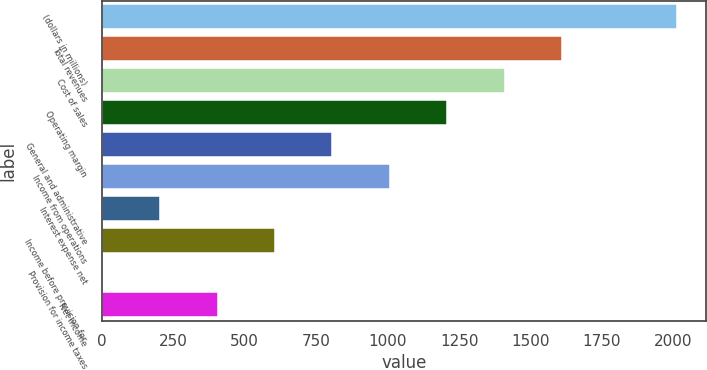Convert chart. <chart><loc_0><loc_0><loc_500><loc_500><bar_chart><fcel>(dollars in millions)<fcel>Total revenues<fcel>Cost of sales<fcel>Operating margin<fcel>General and administrative<fcel>Income from operations<fcel>Interest expense net<fcel>Income before provision for<fcel>Provision for income taxes<fcel>Net income<nl><fcel>2012<fcel>1610.42<fcel>1409.63<fcel>1208.84<fcel>807.26<fcel>1008.05<fcel>204.89<fcel>606.47<fcel>4.1<fcel>405.68<nl></chart> 